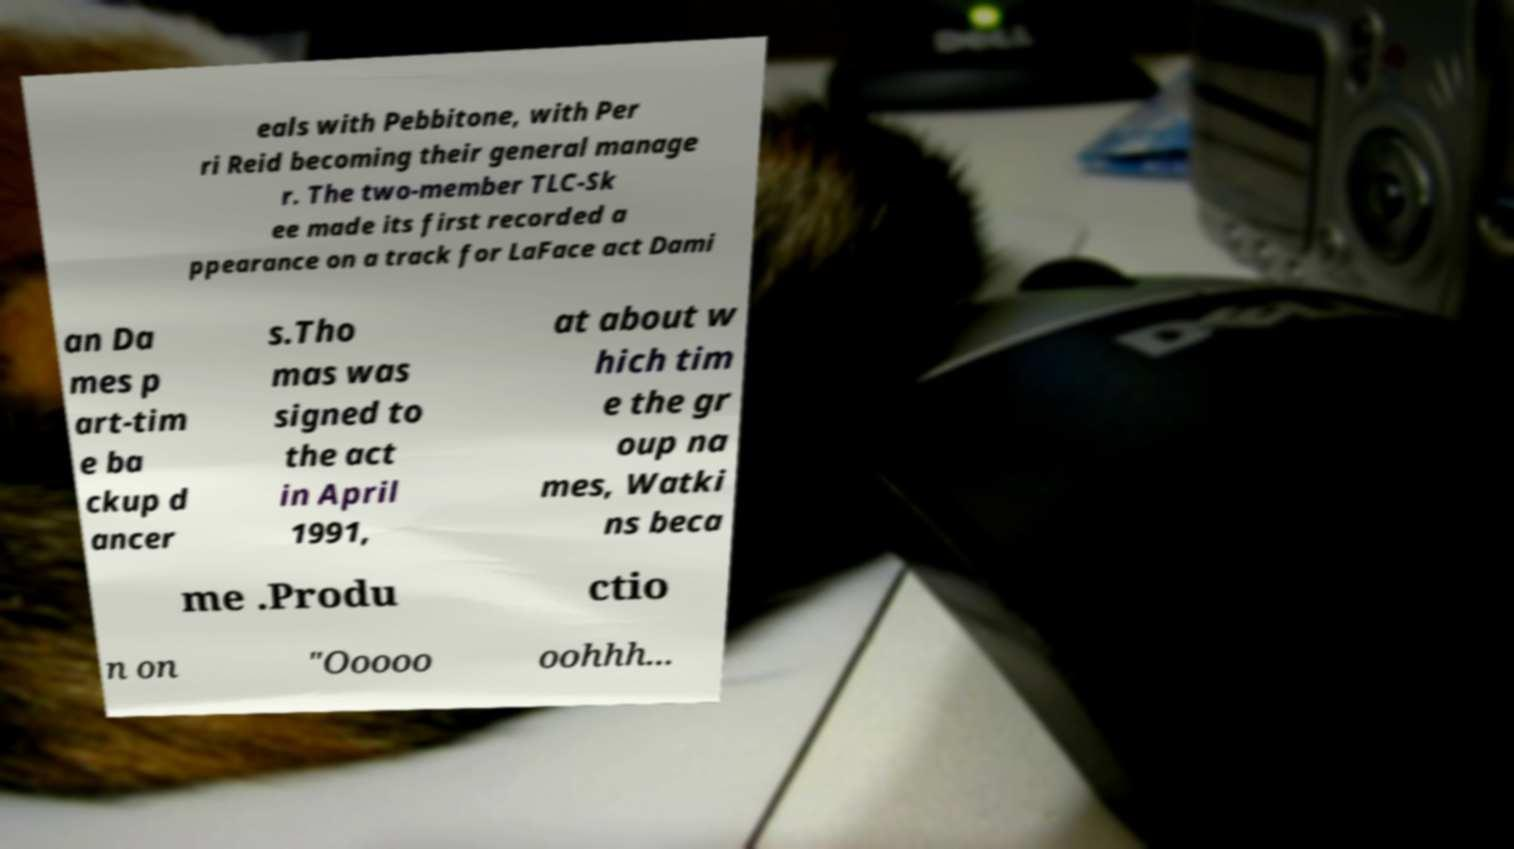For documentation purposes, I need the text within this image transcribed. Could you provide that? eals with Pebbitone, with Per ri Reid becoming their general manage r. The two-member TLC-Sk ee made its first recorded a ppearance on a track for LaFace act Dami an Da mes p art-tim e ba ckup d ancer s.Tho mas was signed to the act in April 1991, at about w hich tim e the gr oup na mes, Watki ns beca me .Produ ctio n on "Ooooo oohhh... 